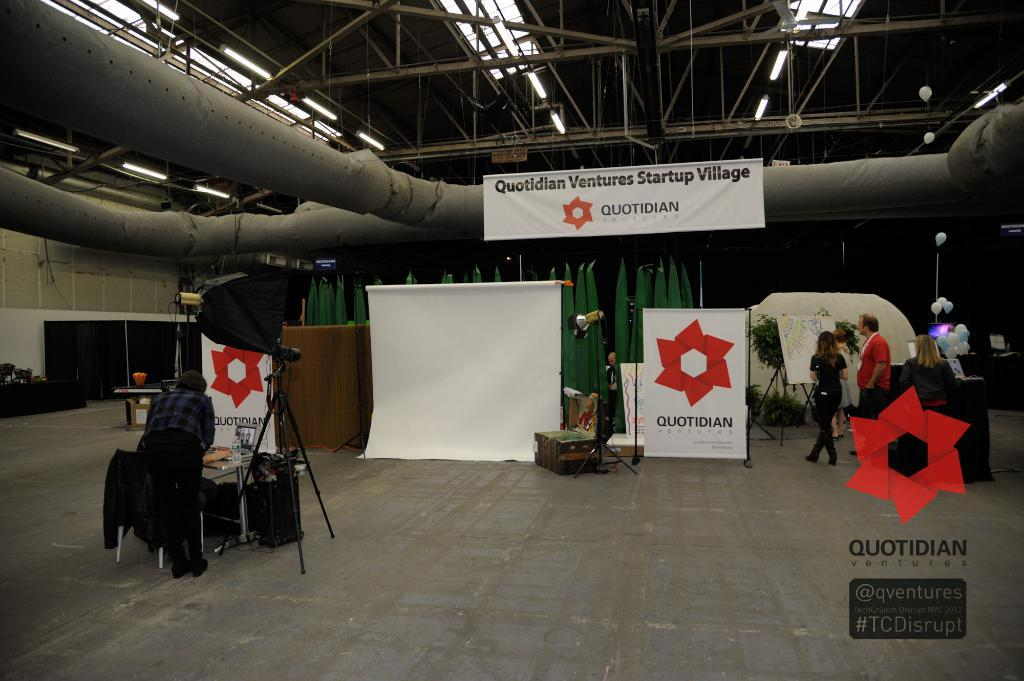Provide a one-sentence caption for the provided image. A white banner bearing the name Quotidian is hung on a pipe. 